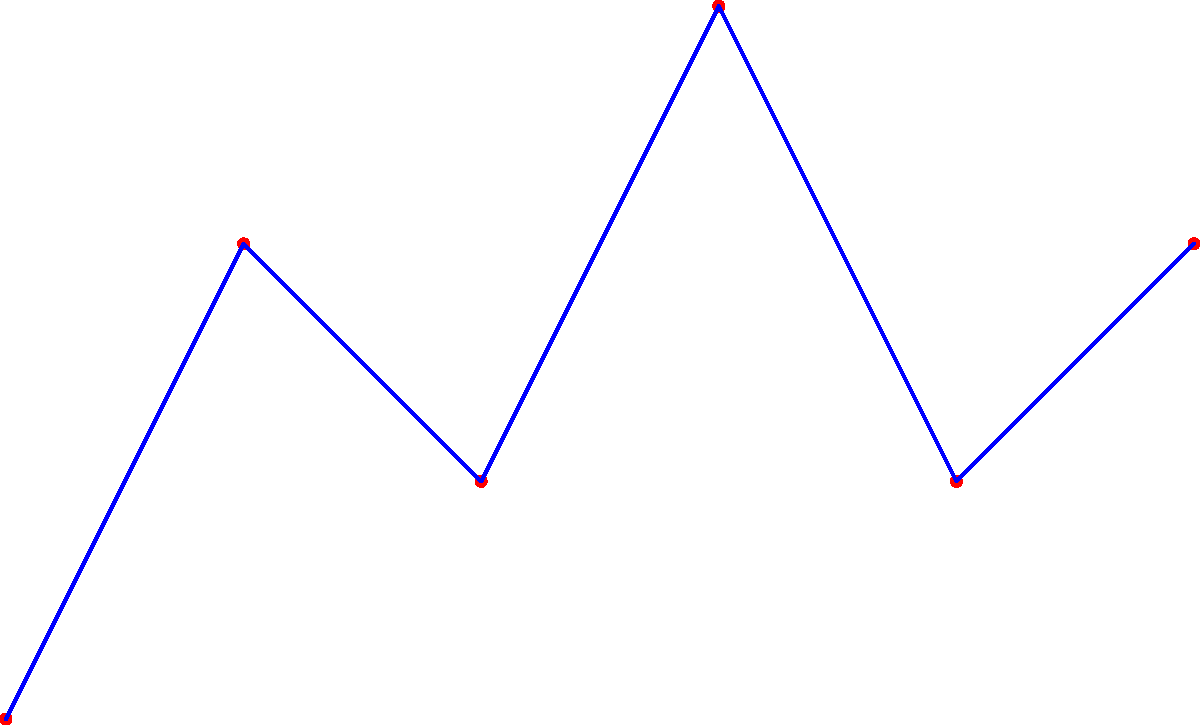Which famous constellation does this star pattern resemble, often associated with a mythological hunter? 1. Observe the arrangement of stars in the diagram.
2. Note the distinctive pattern: three stars in a row (the belt) with four outer stars forming a rough rectangle.
3. This pattern is characteristic of Orion, one of the most recognizable constellations in the night sky.
4. In mythology, Orion is depicted as a hunter, with the three stars in a line representing his belt.
5. The four outer stars represent his shoulders and feet.
6. This constellation is visible from both hemispheres and is particularly prominent in winter nights in the Northern Hemisphere.
7. Orion is often used as a starting point to locate other constellations due to its distinctive shape and brightness.
Answer: Orion 